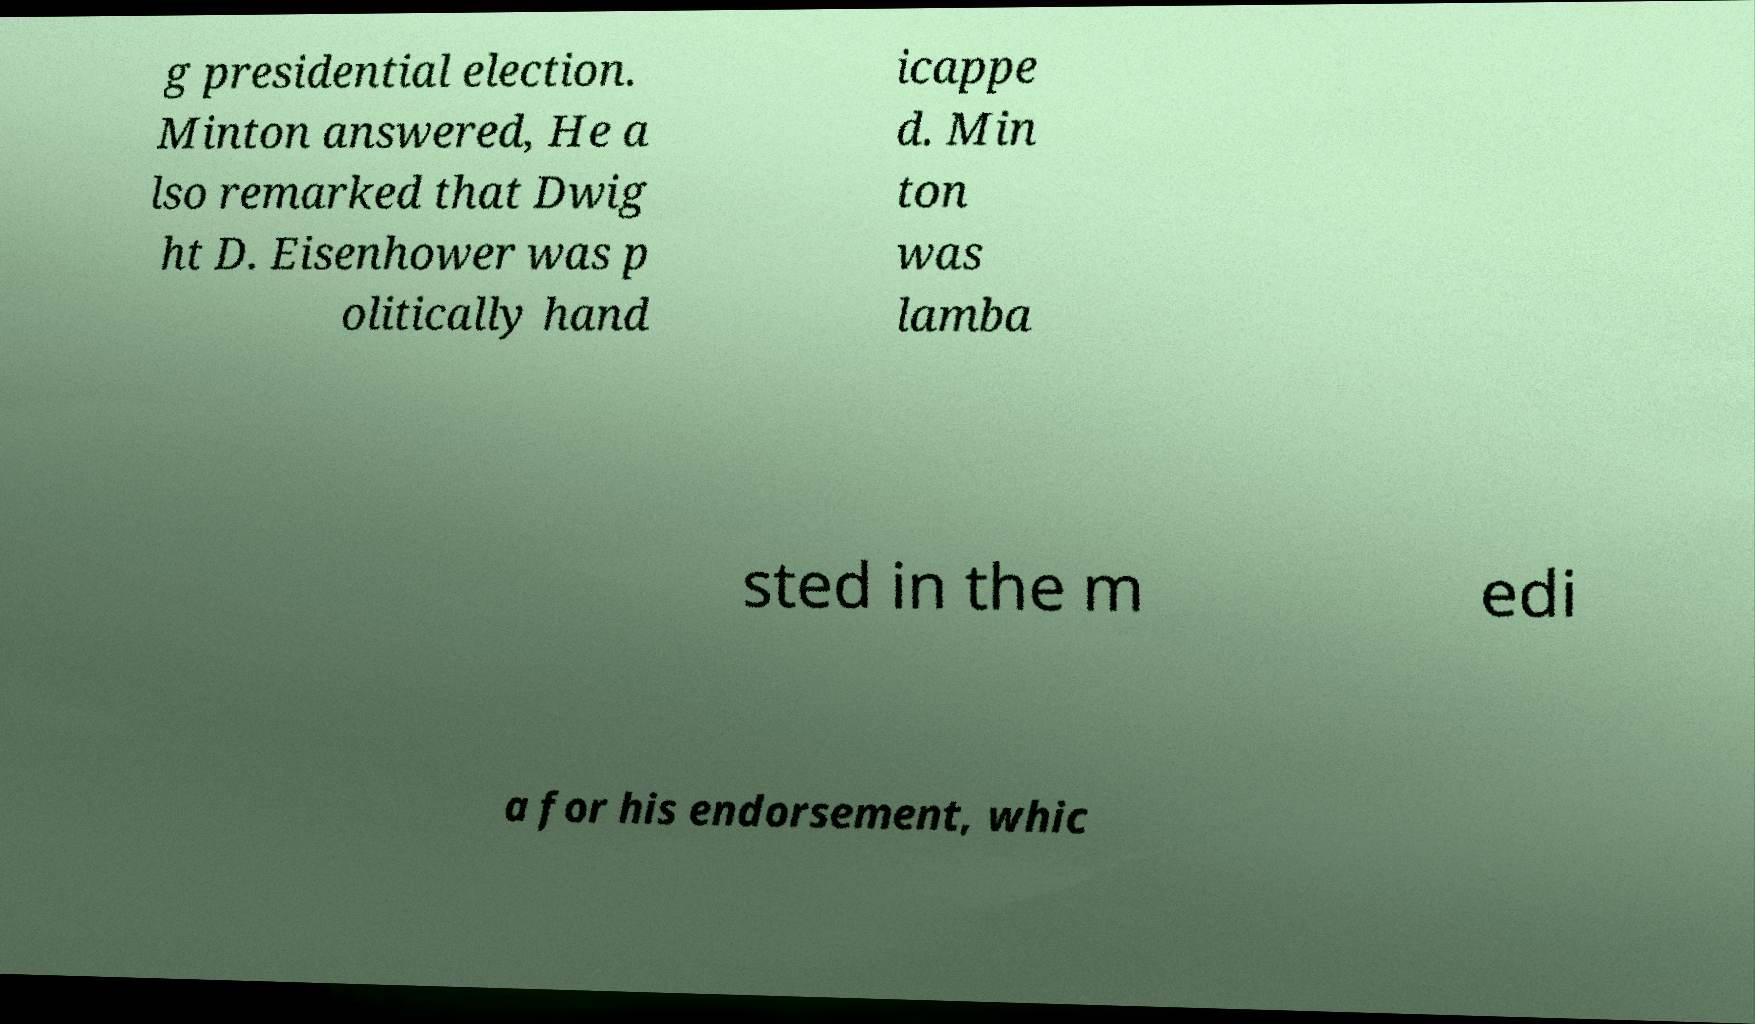Could you assist in decoding the text presented in this image and type it out clearly? g presidential election. Minton answered, He a lso remarked that Dwig ht D. Eisenhower was p olitically hand icappe d. Min ton was lamba sted in the m edi a for his endorsement, whic 